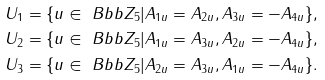Convert formula to latex. <formula><loc_0><loc_0><loc_500><loc_500>U _ { 1 } & = \{ u \in \ B b b { Z } _ { 5 } | A _ { 1 u } = A _ { 2 u } , A _ { 3 u } = - A _ { 4 u } \} , \\ U _ { 2 } & = \{ u \in \ B b b { Z } _ { 5 } | A _ { 1 u } = A _ { 3 u } , A _ { 2 u } = - A _ { 4 u } \} , \\ U _ { 3 } & = \{ u \in \ B b b { Z } _ { 5 } | A _ { 2 u } = A _ { 3 u } , A _ { 1 u } = - A _ { 4 u } \} .</formula> 